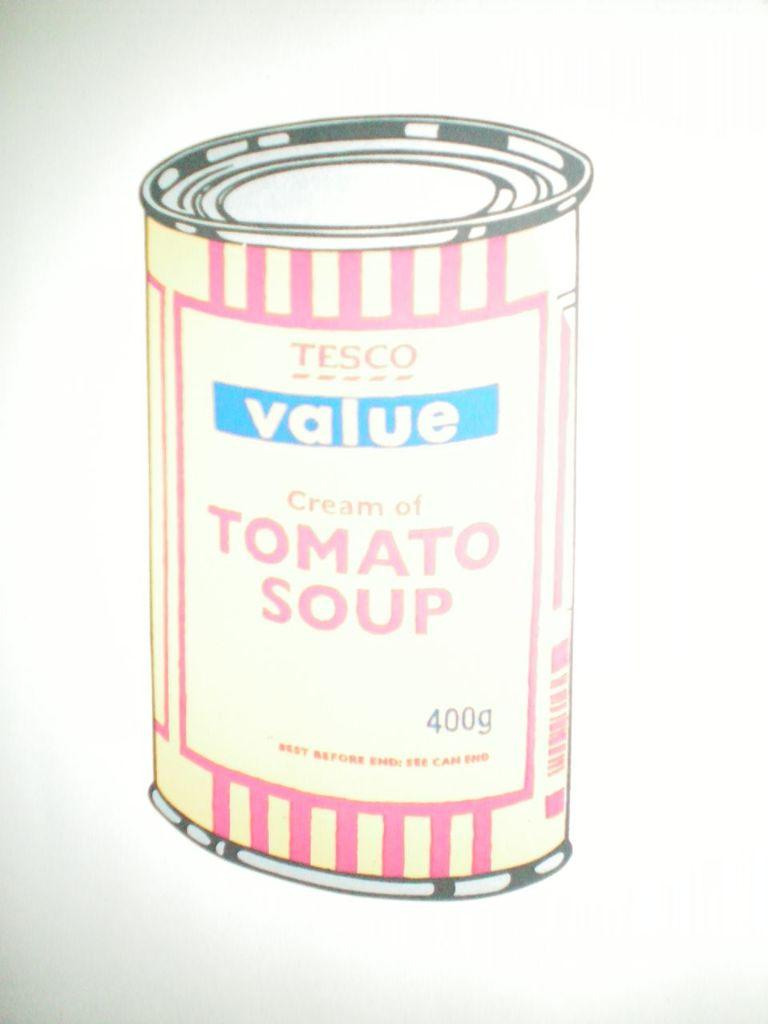<image>
Provide a brief description of the given image. A drawing of a tomato soup can is shown. 